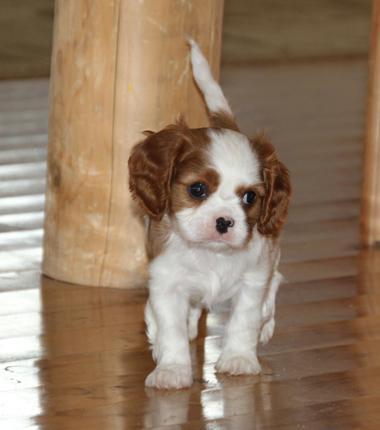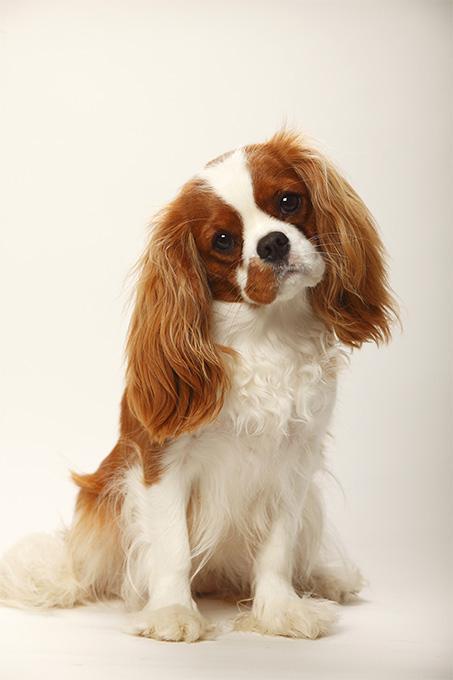The first image is the image on the left, the second image is the image on the right. For the images shown, is this caption "There are three mammals visible" true? Answer yes or no. No. The first image is the image on the left, the second image is the image on the right. Analyze the images presented: Is the assertion "Two animals, including at least one spaniel dog, pose side-by-side in one image." valid? Answer yes or no. No. 